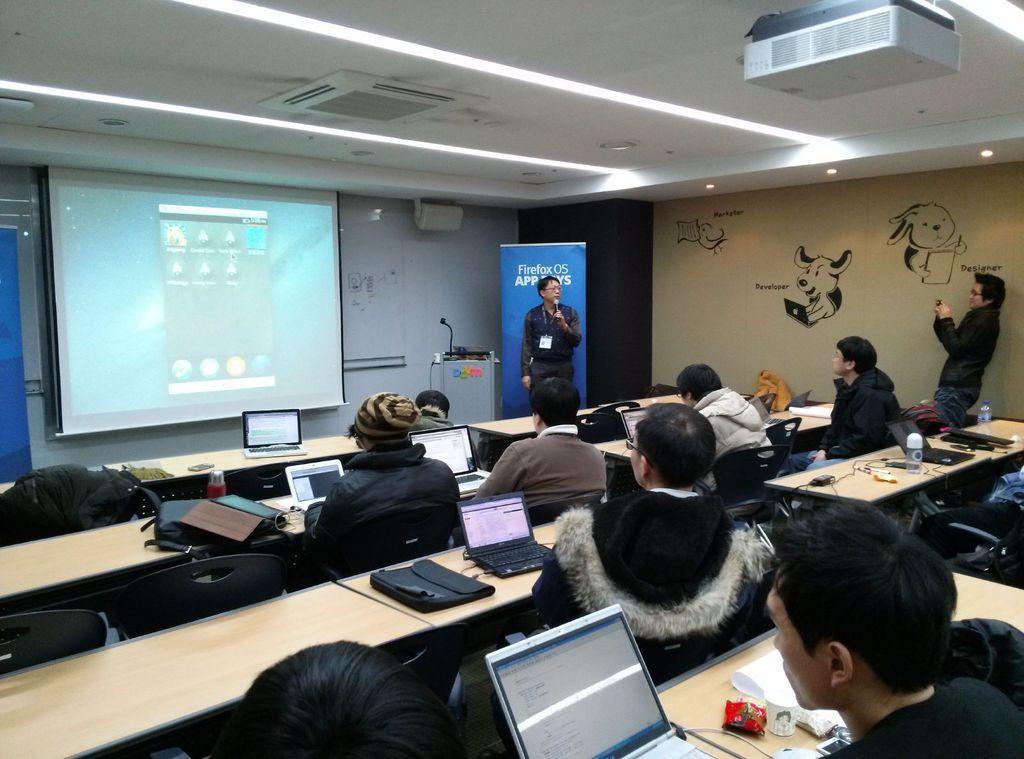Please provide a concise description of this image. In this image we can see many persons sitting at the laptops and we can also see benches. On the bench we can see bag, water bottles, laptops. In the background we can see person standing and holding a mic, screen, mic and drawings on wall. At the top of the image there is projector. 